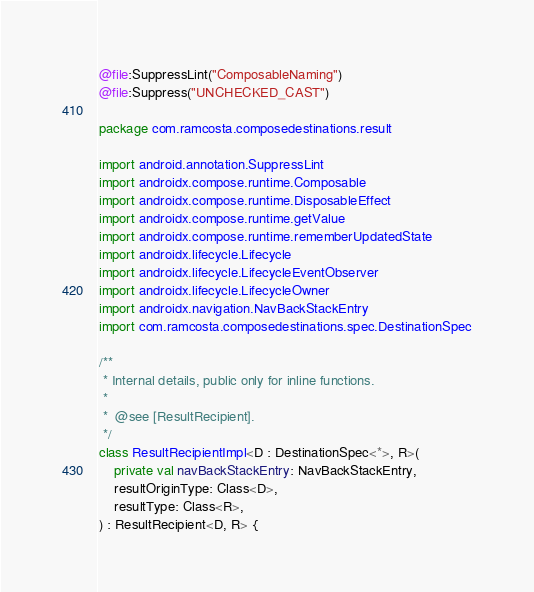<code> <loc_0><loc_0><loc_500><loc_500><_Kotlin_>@file:SuppressLint("ComposableNaming")
@file:Suppress("UNCHECKED_CAST")

package com.ramcosta.composedestinations.result

import android.annotation.SuppressLint
import androidx.compose.runtime.Composable
import androidx.compose.runtime.DisposableEffect
import androidx.compose.runtime.getValue
import androidx.compose.runtime.rememberUpdatedState
import androidx.lifecycle.Lifecycle
import androidx.lifecycle.LifecycleEventObserver
import androidx.lifecycle.LifecycleOwner
import androidx.navigation.NavBackStackEntry
import com.ramcosta.composedestinations.spec.DestinationSpec

/**
 * Internal details, public only for inline functions.
 *
 *  @see [ResultRecipient].
 */
class ResultRecipientImpl<D : DestinationSpec<*>, R>(
    private val navBackStackEntry: NavBackStackEntry,
    resultOriginType: Class<D>,
    resultType: Class<R>,
) : ResultRecipient<D, R> {
</code> 